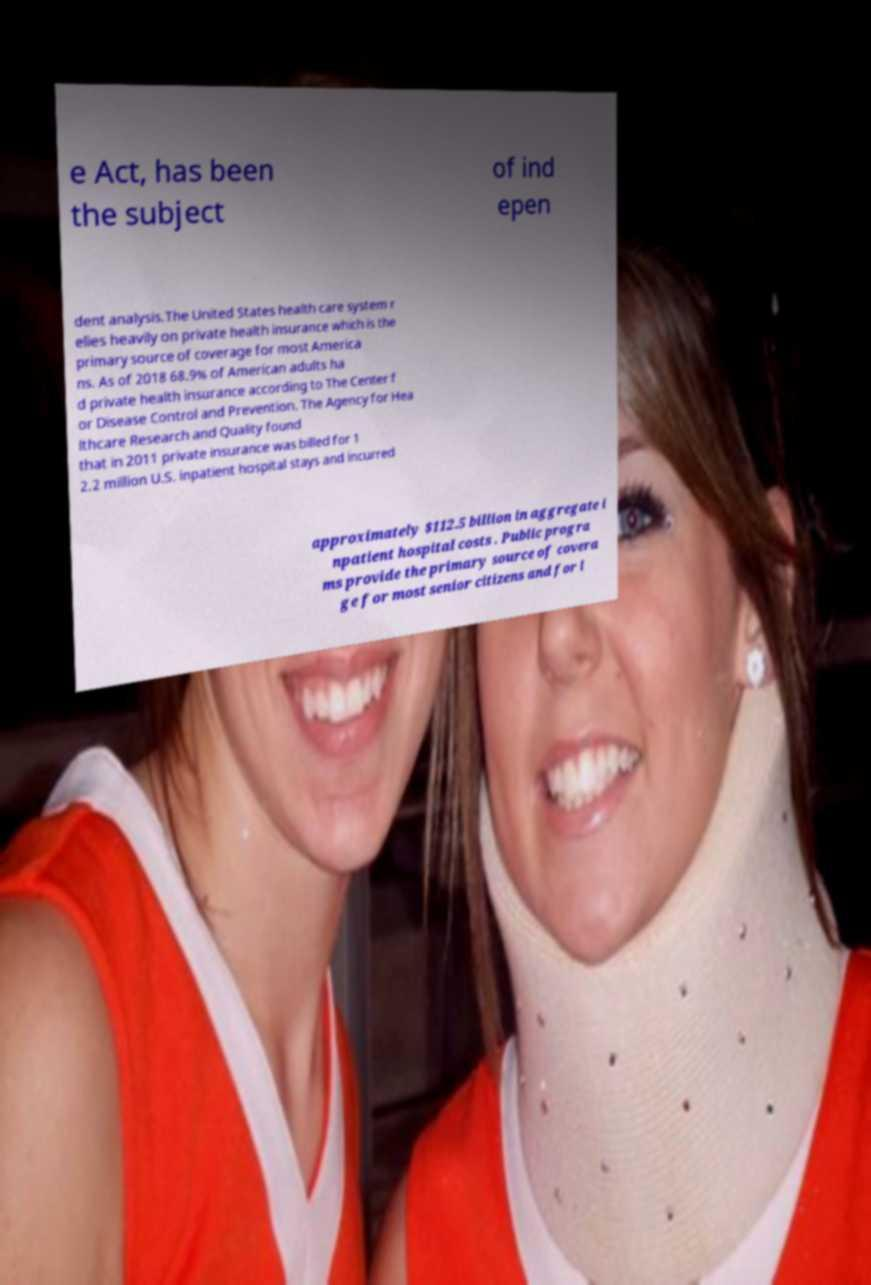Can you read and provide the text displayed in the image?This photo seems to have some interesting text. Can you extract and type it out for me? e Act, has been the subject of ind epen dent analysis.The United States health care system r elies heavily on private health insurance which is the primary source of coverage for most America ns. As of 2018 68.9% of American adults ha d private health insurance according to The Center f or Disease Control and Prevention. The Agency for Hea lthcare Research and Quality found that in 2011 private insurance was billed for 1 2.2 million U.S. inpatient hospital stays and incurred approximately $112.5 billion in aggregate i npatient hospital costs . Public progra ms provide the primary source of covera ge for most senior citizens and for l 